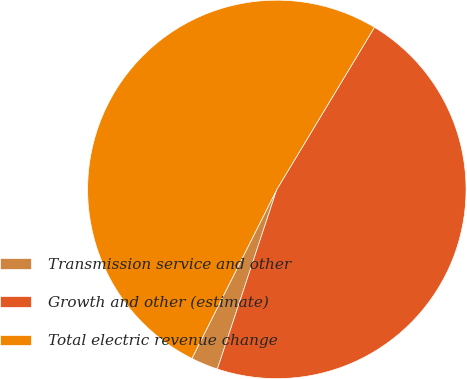Convert chart. <chart><loc_0><loc_0><loc_500><loc_500><pie_chart><fcel>Transmission service and other<fcel>Growth and other (estimate)<fcel>Total electric revenue change<nl><fcel>2.32%<fcel>46.46%<fcel>51.22%<nl></chart> 